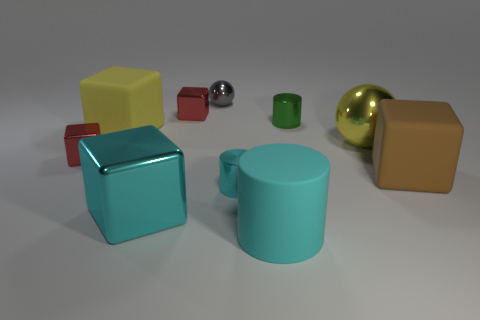If you had to guess, what material do the objects in the image look like they're made of? The objects in the image appear to have a smooth texture. The cubes and cylinder might be made of a matte plastic, while the spheres, particularly the shiny gold and silver ones, suggest a metallic material due to their reflective surfaces. 